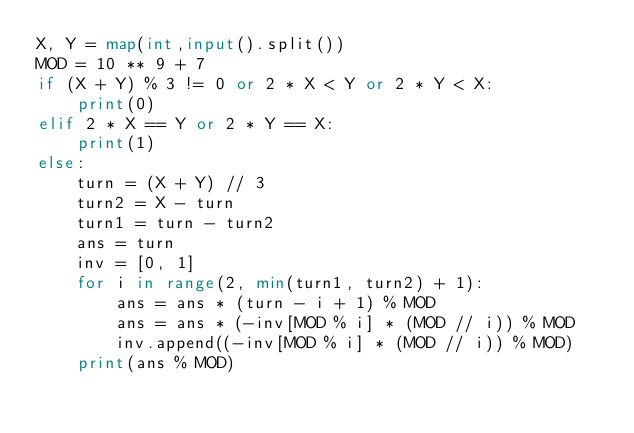Convert code to text. <code><loc_0><loc_0><loc_500><loc_500><_Python_>X, Y = map(int,input().split())
MOD = 10 ** 9 + 7
if (X + Y) % 3 != 0 or 2 * X < Y or 2 * Y < X:
    print(0)
elif 2 * X == Y or 2 * Y == X:
    print(1)
else:
    turn = (X + Y) // 3
    turn2 = X - turn
    turn1 = turn - turn2
    ans = turn
    inv = [0, 1]
    for i in range(2, min(turn1, turn2) + 1):
        ans = ans * (turn - i + 1) % MOD
        ans = ans * (-inv[MOD % i] * (MOD // i)) % MOD
        inv.append((-inv[MOD % i] * (MOD // i)) % MOD)
    print(ans % MOD)</code> 